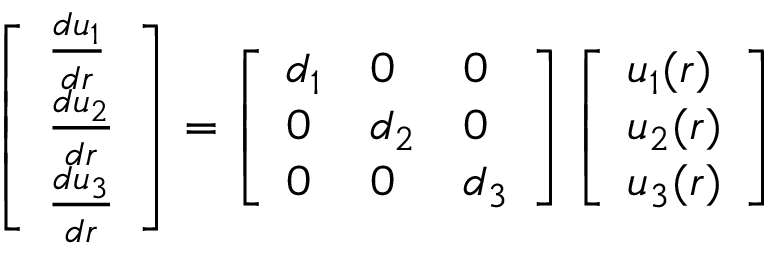Convert formula to latex. <formula><loc_0><loc_0><loc_500><loc_500>\left [ \begin{array} { l } { \frac { d u _ { 1 } } { d r } } \\ { \frac { d u _ { 2 } } { d r } } \\ { \frac { d u _ { 3 } } { d r } } \end{array} \right ] = \left [ \begin{array} { l l l } { d _ { 1 } } & { 0 } & { 0 } \\ { 0 } & { d _ { 2 } } & { 0 } \\ { 0 } & { 0 } & { d _ { 3 } } \end{array} \right ] \left [ \begin{array} { l } { u _ { 1 } ( r ) } \\ { u _ { 2 } ( r ) } \\ { u _ { 3 } ( r ) } \end{array} \right ]</formula> 